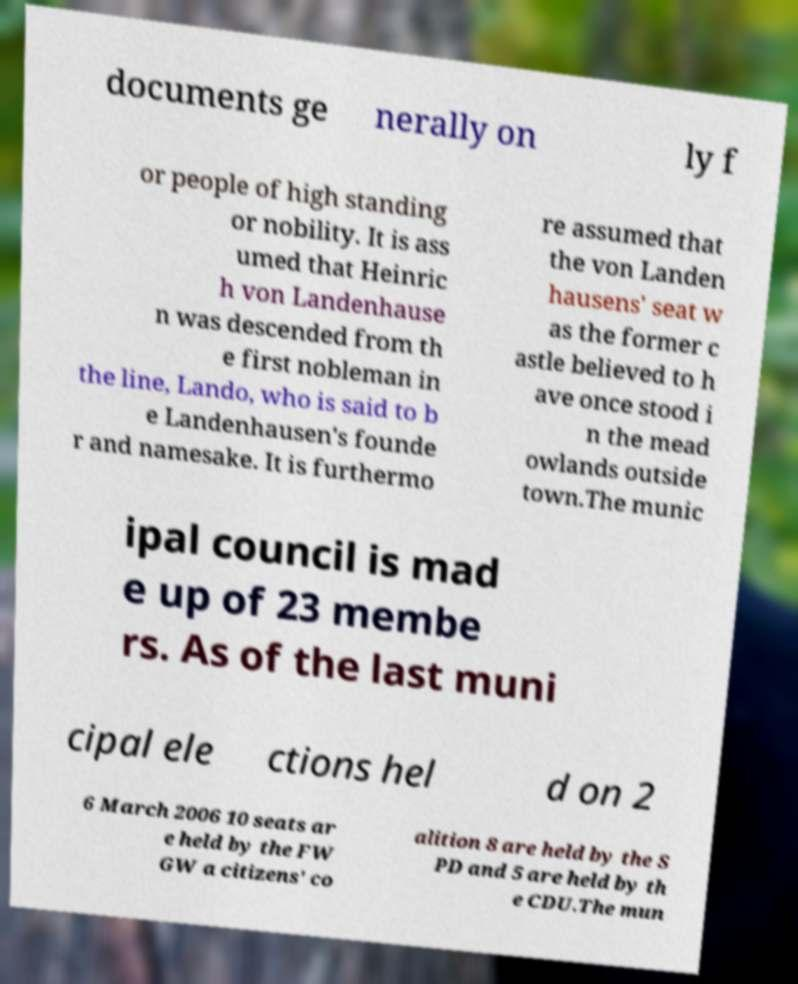Please read and relay the text visible in this image. What does it say? documents ge nerally on ly f or people of high standing or nobility. It is ass umed that Heinric h von Landenhause n was descended from th e first nobleman in the line, Lando, who is said to b e Landenhausen's founde r and namesake. It is furthermo re assumed that the von Landen hausens' seat w as the former c astle believed to h ave once stood i n the mead owlands outside town.The munic ipal council is mad e up of 23 membe rs. As of the last muni cipal ele ctions hel d on 2 6 March 2006 10 seats ar e held by the FW GW a citizens' co alition 8 are held by the S PD and 5 are held by th e CDU.The mun 